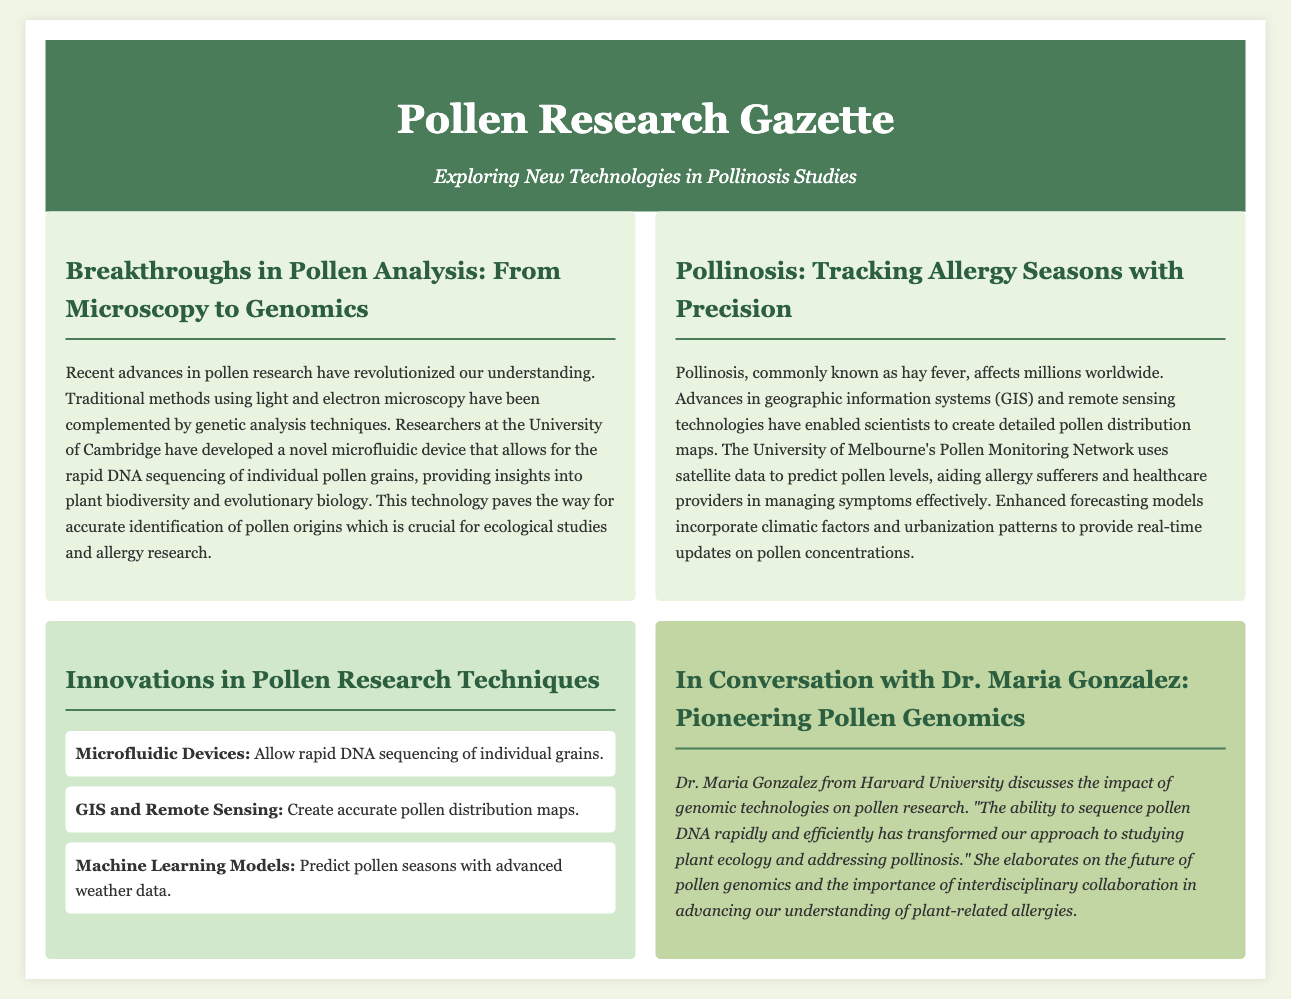what recent technology has improved pollen analysis? The document mentions a novel microfluidic device developed by researchers at the University of Cambridge for rapid DNA sequencing of individual pollen grains.
Answer: microfluidic device what is the main benefit of the Pollen Monitoring Network? It uses satellite data to predict pollen levels, aiding allergy sufferers and healthcare providers in managing symptoms effectively.
Answer: predict pollen levels who is Dr. Maria Gonzalez? The document introduces Dr. Maria Gonzalez as a researcher from Harvard University who discusses the impact of genomic technologies on pollen research.
Answer: Harvard University what are the three innovations listed in the infographic? The infographic lists microfluidic devices, GIS and remote sensing, and machine learning models as innovations in pollen research techniques.
Answer: microfluidic devices, GIS and remote sensing, machine learning models what is the primary focus of the article "Pollinosis: Tracking Allergy Seasons with Precision"? The article focuses on the advancements in tracking pollinosis through geographic information systems and remote sensing technologies to create pollen distribution maps.
Answer: advancements in tracking pollinosis what does Dr. Maria Gonzalez say about rapid pollen DNA sequencing? Dr. Gonzalez states that the ability to sequence pollen DNA rapidly and efficiently has transformed their approach to studying plant ecology and addressing pollinosis.
Answer: transformed approach how have models improved pollen season prediction? Enhanced forecasting models incorporate climatic factors and urbanization patterns for more accurate predictions of pollen seasons.
Answer: climatic factors and urbanization patterns what background detail does the document provide about the significance of pollen research? The document explains that accurate identification of pollen origins is crucial for ecological studies and allergy research.
Answer: ecological studies and allergy research 